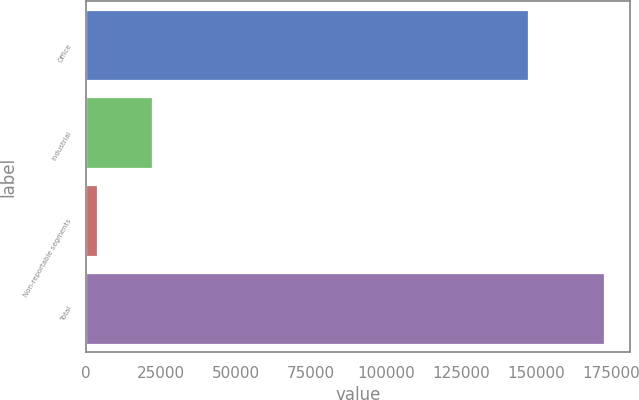Convert chart to OTSL. <chart><loc_0><loc_0><loc_500><loc_500><bar_chart><fcel>Office<fcel>Industrial<fcel>Non-reportable segments<fcel>Total<nl><fcel>147387<fcel>21890<fcel>3519<fcel>172796<nl></chart> 